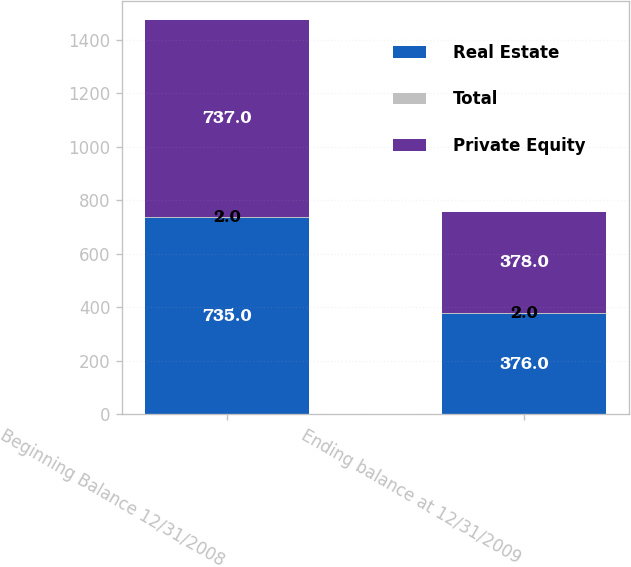Convert chart. <chart><loc_0><loc_0><loc_500><loc_500><stacked_bar_chart><ecel><fcel>Beginning Balance 12/31/2008<fcel>Ending balance at 12/31/2009<nl><fcel>Real Estate<fcel>735<fcel>376<nl><fcel>Total<fcel>2<fcel>2<nl><fcel>Private Equity<fcel>737<fcel>378<nl></chart> 